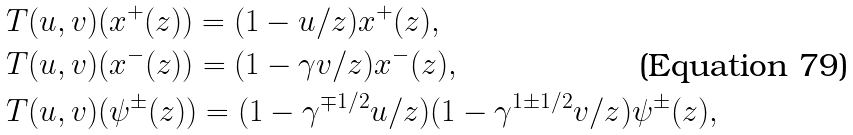Convert formula to latex. <formula><loc_0><loc_0><loc_500><loc_500>& T ( u , v ) ( x ^ { + } ( z ) ) = ( 1 - u / z ) x ^ { + } ( z ) , \\ & T ( u , v ) ( x ^ { - } ( z ) ) = ( 1 - \gamma v / z ) x ^ { - } ( z ) , \\ & T ( u , v ) ( \psi ^ { \pm } ( z ) ) = ( 1 - \gamma ^ { \mp 1 / 2 } u / z ) ( 1 - \gamma ^ { 1 \pm 1 / 2 } v / z ) \psi ^ { \pm } ( z ) ,</formula> 